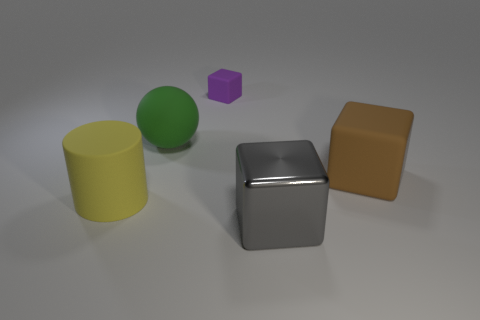Is there any other thing that has the same material as the large gray block?
Your answer should be compact. No. Are there any other things that have the same color as the sphere?
Keep it short and to the point. No. What number of blocks are on the right side of the matte cube behind the large brown matte object?
Make the answer very short. 2. Are the green sphere and the large brown thing made of the same material?
Give a very brief answer. Yes. There is a thing in front of the rubber object that is to the left of the big green rubber object; what number of matte cubes are behind it?
Your answer should be very brief. 2. What is the color of the large cube in front of the yellow rubber cylinder?
Make the answer very short. Gray. The large matte object that is on the right side of the purple matte thing to the right of the large yellow cylinder is what shape?
Ensure brevity in your answer.  Cube. What number of cylinders are big green things or shiny things?
Give a very brief answer. 0. The block that is both to the left of the brown rubber object and in front of the small rubber block is made of what material?
Keep it short and to the point. Metal. How many purple rubber things are to the left of the small matte object?
Your response must be concise. 0. 